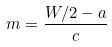Convert formula to latex. <formula><loc_0><loc_0><loc_500><loc_500>m = \frac { W / 2 - a } { c }</formula> 